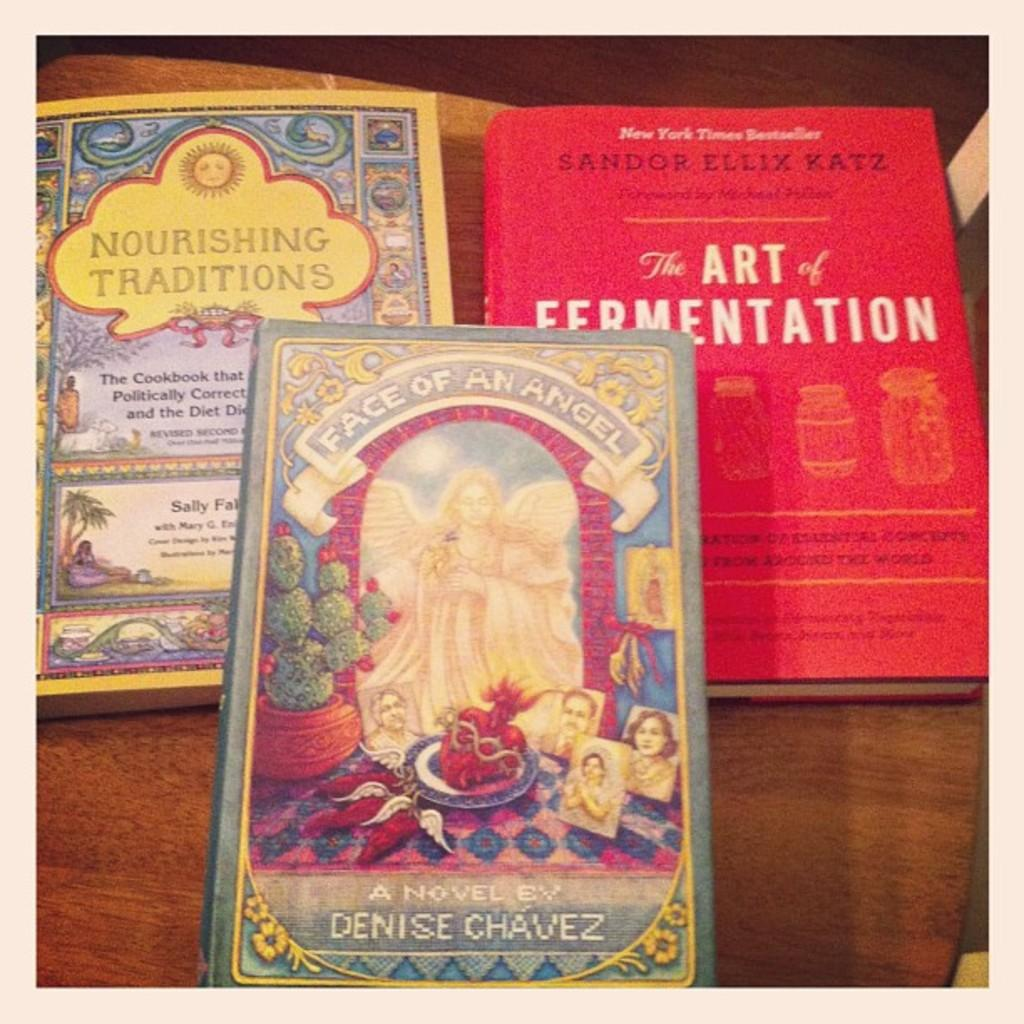Provide a one-sentence caption for the provided image. Three books entitled a Face of an Angel, the Art of Fermentation, and Nourishing Traditions. 